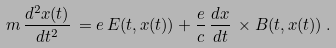<formula> <loc_0><loc_0><loc_500><loc_500>m \, \frac { d ^ { 2 } x ( t ) } { d t ^ { 2 } } \, = e \, E ( t , x ( t ) ) + \frac { e } { c } \, \frac { d x } { d t } \, \times B ( t , x ( t ) ) \, .</formula> 